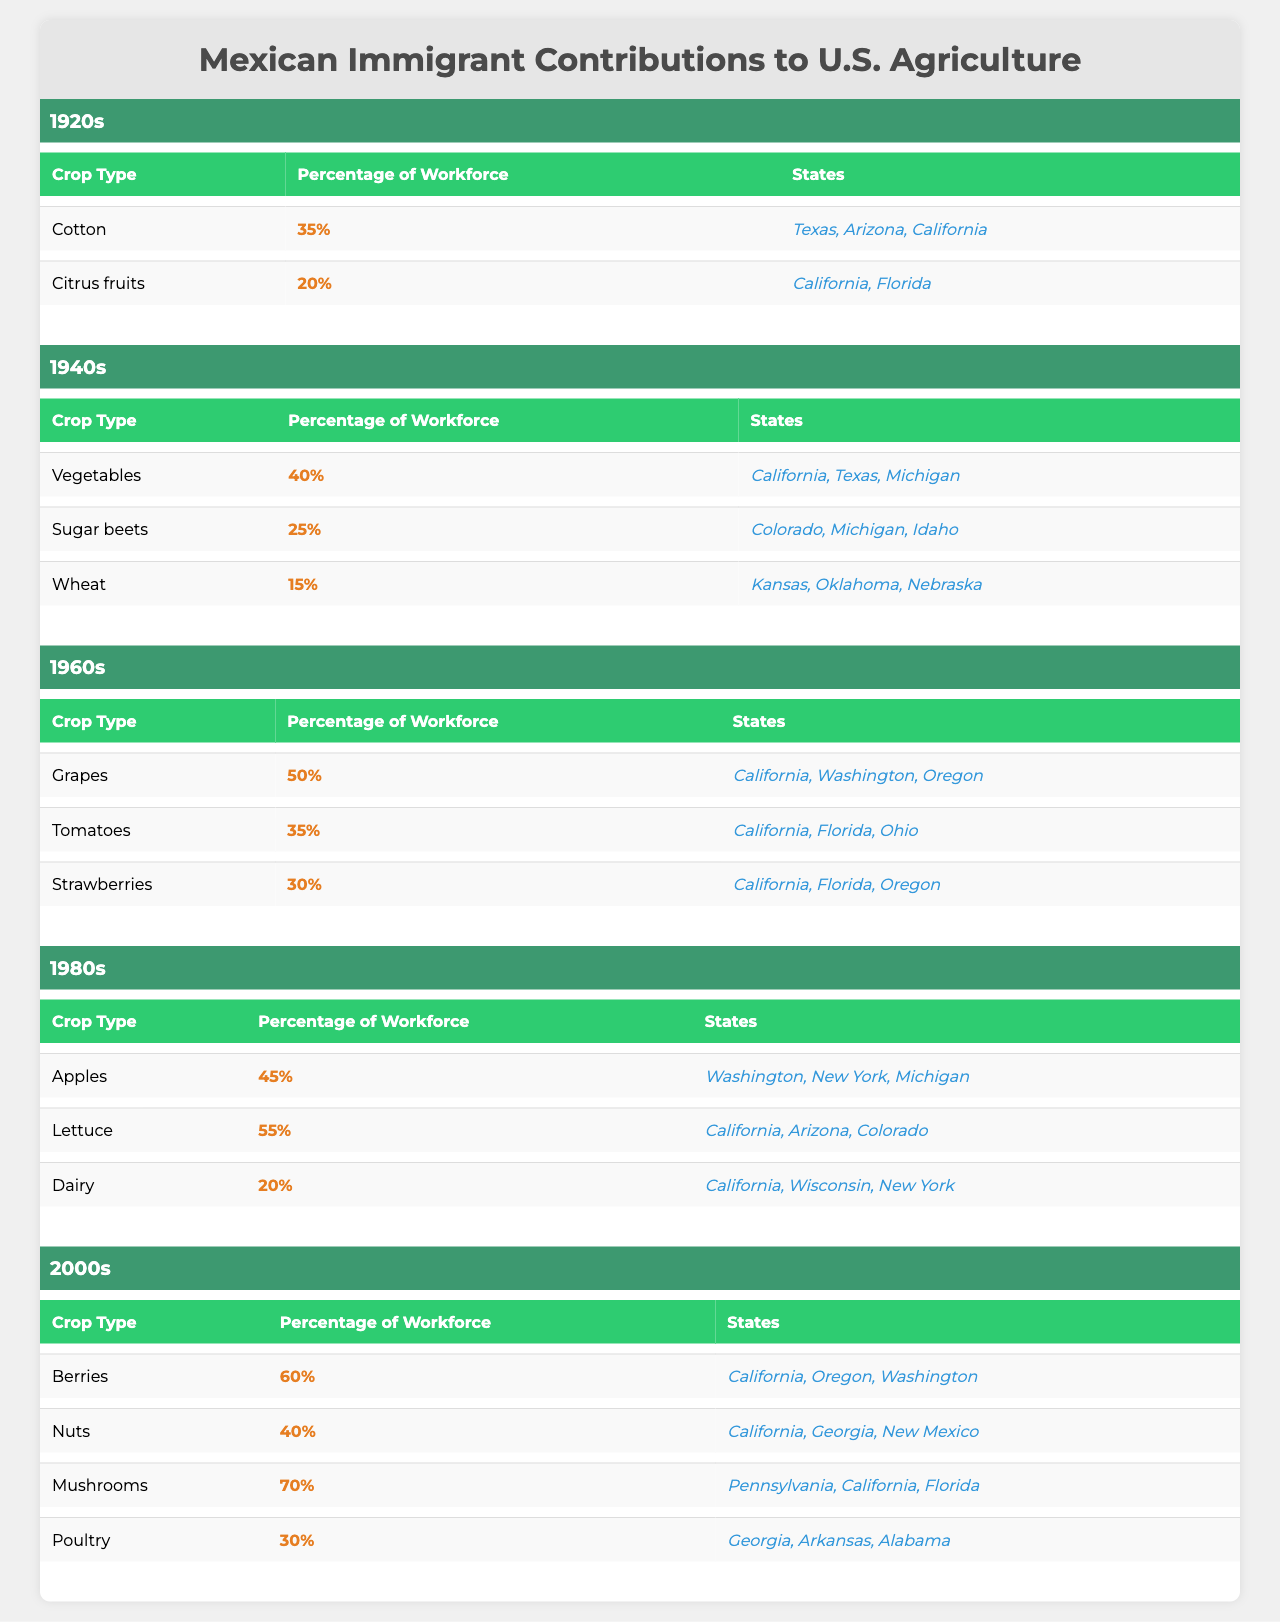What was the crop type with the highest percentage of workforce in the 1940s? In the 1940s, the table shows that "Vegetables" had the highest percentage of workforce, which is 40%.
Answer: Vegetables Which decade had the highest contribution of Mexican immigrants to U.S. agriculture in terms of the percentage of workforce for mushrooms? The 2000s had the highest contribution for mushrooms, with a percentage of 70% of the workforce.
Answer: 2000s True or False: In the 1920s, the contribution of Mexican immigrants to the citrus fruits crop was higher than that of cotton. The table shows that cotton had 35% and citrus fruits had 20%. Therefore, this statement is false.
Answer: False What is the average percentage of the workforce in the 1980s for the listed crops? The percentages for the 1980s crops are 45% (Apples), 55% (Lettuce), and 20% (Dairy). The average is calculated as (45 + 55 + 20) / 3 = 120 / 3 = 40%.
Answer: 40% Which states were involved in the production of sugar beets in the 1940s? The table lists Colorado, Michigan, and Idaho as the states involved in sugar beet production in the 1940s.
Answer: Colorado, Michigan, Idaho What is the difference in percentage of workforce between strawberries and tomatoes in the 1960s? In the 1960s, strawberries comprised 30% of the workforce, while tomatoes made up 35%. The difference is 35% - 30% = 5%.
Answer: 5% Which crop type in the 2000s had the lowest percentage of workforce, and what was that percentage? In the 2000s, poultry had the lowest percentage of workforce at 30%.
Answer: Poultry, 30% How many different crop types were Mexican immigrants involved with in the 1980s and what percentage of workforce did they contribute collectively? The crops in the 1980s were Apples (45%), Lettuce (55%), and Dairy (20%). The total percentage is 45 + 55 + 20 = 120%. There are 3 crop types.
Answer: 3 types, 120% In which decade did the production of lettuce see its highest workforce contribution and what was this contribution? The table indicates that lettuce had the highest contribution of 55% in the 1980s.
Answer: 1980s, 55% What is the total percentage of workforce for the top three crops in the 2000s? The top three crops in the 2000s are Berries (60%), Nuts (40%), and Mushrooms (70%). The total percentage adds up to 60 + 40 + 70 = 170%.
Answer: 170% 